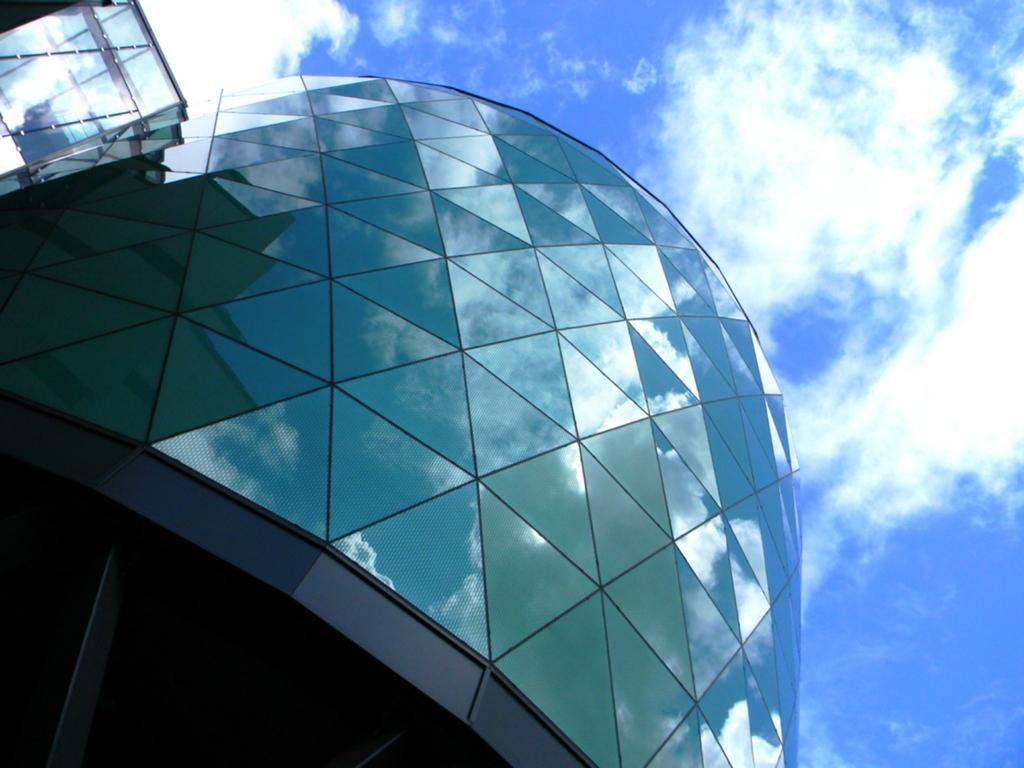What type of structure is visible in the image? There is a building in the image. What is the condition of the sky in the image? The sky in the image is blue and cloudy. Can you describe the reflection in the image? The blue and cloudy sky is reflected in the image. What brand of toothpaste is advertised on the building in the image? There is no toothpaste or advertisement visible on the building in the image. Can you describe the snake that is slithering across the building in the image? There is no snake present in the image; it only features a building and a blue and cloudy sky. 